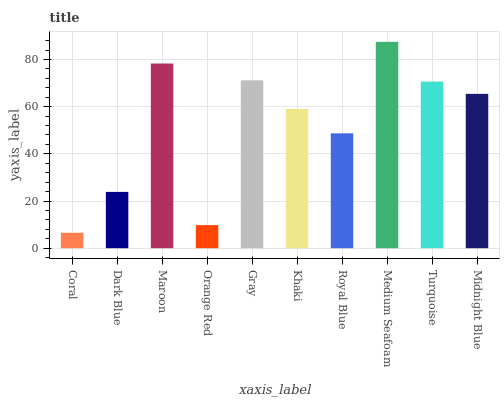Is Coral the minimum?
Answer yes or no. Yes. Is Medium Seafoam the maximum?
Answer yes or no. Yes. Is Dark Blue the minimum?
Answer yes or no. No. Is Dark Blue the maximum?
Answer yes or no. No. Is Dark Blue greater than Coral?
Answer yes or no. Yes. Is Coral less than Dark Blue?
Answer yes or no. Yes. Is Coral greater than Dark Blue?
Answer yes or no. No. Is Dark Blue less than Coral?
Answer yes or no. No. Is Midnight Blue the high median?
Answer yes or no. Yes. Is Khaki the low median?
Answer yes or no. Yes. Is Maroon the high median?
Answer yes or no. No. Is Gray the low median?
Answer yes or no. No. 